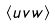Convert formula to latex. <formula><loc_0><loc_0><loc_500><loc_500>\langle { u v w \rangle }</formula> 